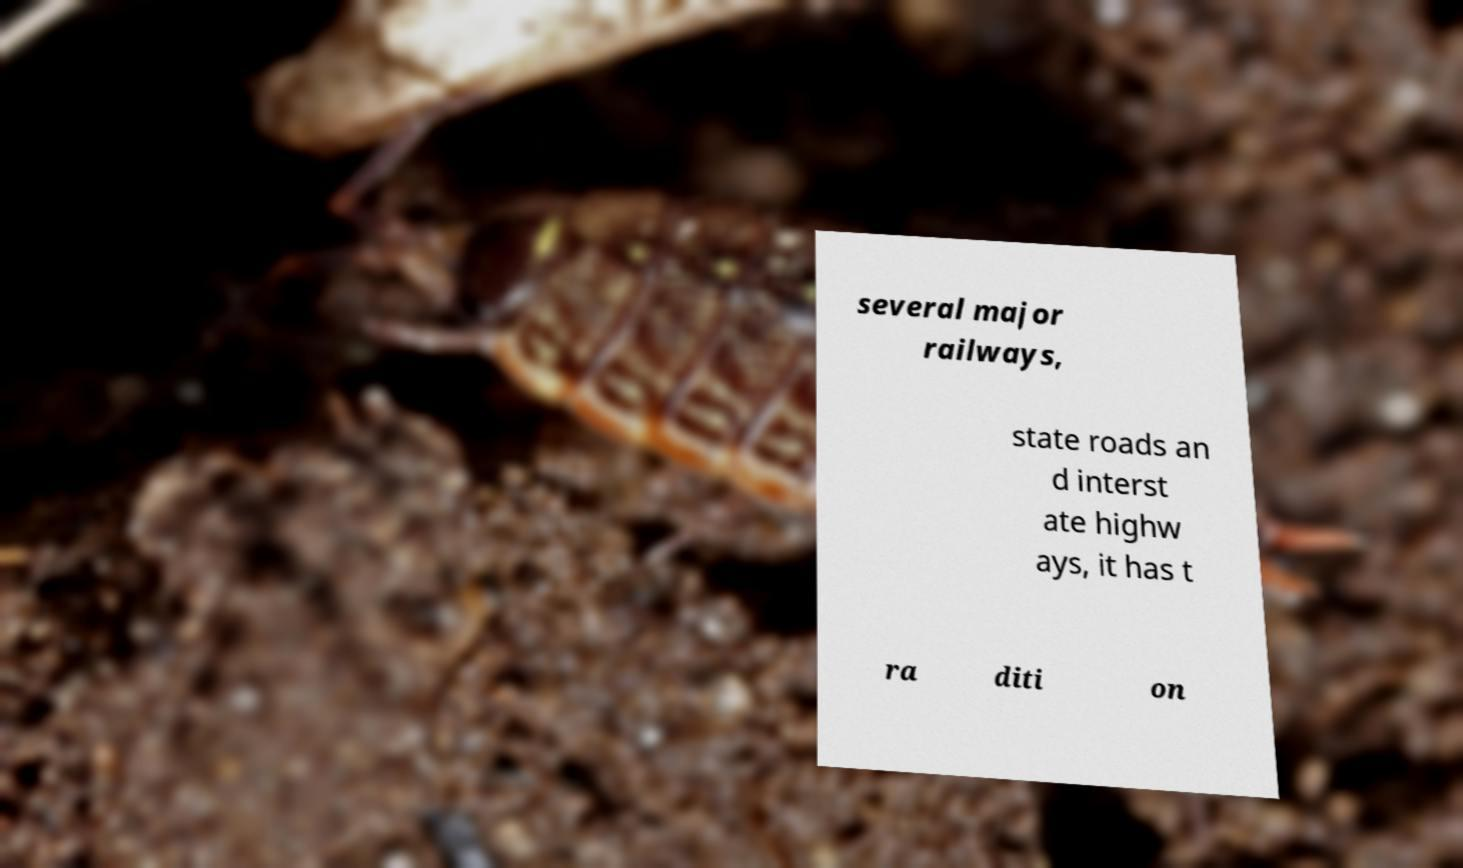I need the written content from this picture converted into text. Can you do that? several major railways, state roads an d interst ate highw ays, it has t ra diti on 